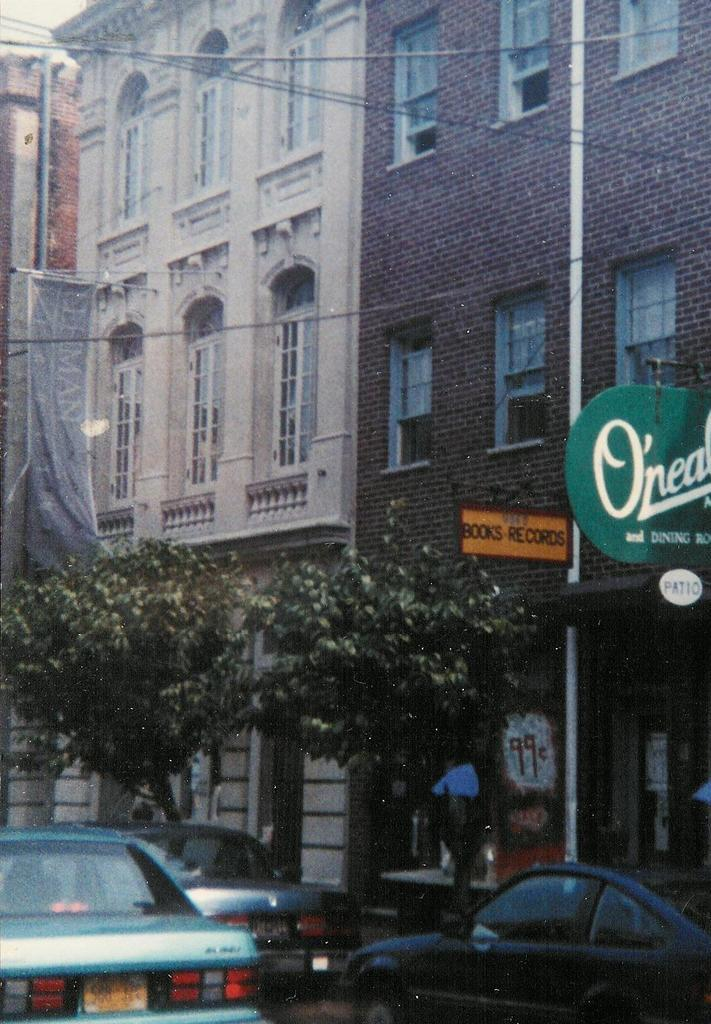What type of natural elements can be seen in the image? There are trees in the image. What man-made objects are present in the image? There are cars in the image. Where are the trees and cars located in the image? The trees and cars are at the bottom of the image. What can be seen in the distance in the image? There are buildings in the background of the image. What type of appliance is being offered by the trees in the image? There is no appliance being offered by the trees in the image; the trees are natural elements and do not offer appliances. 